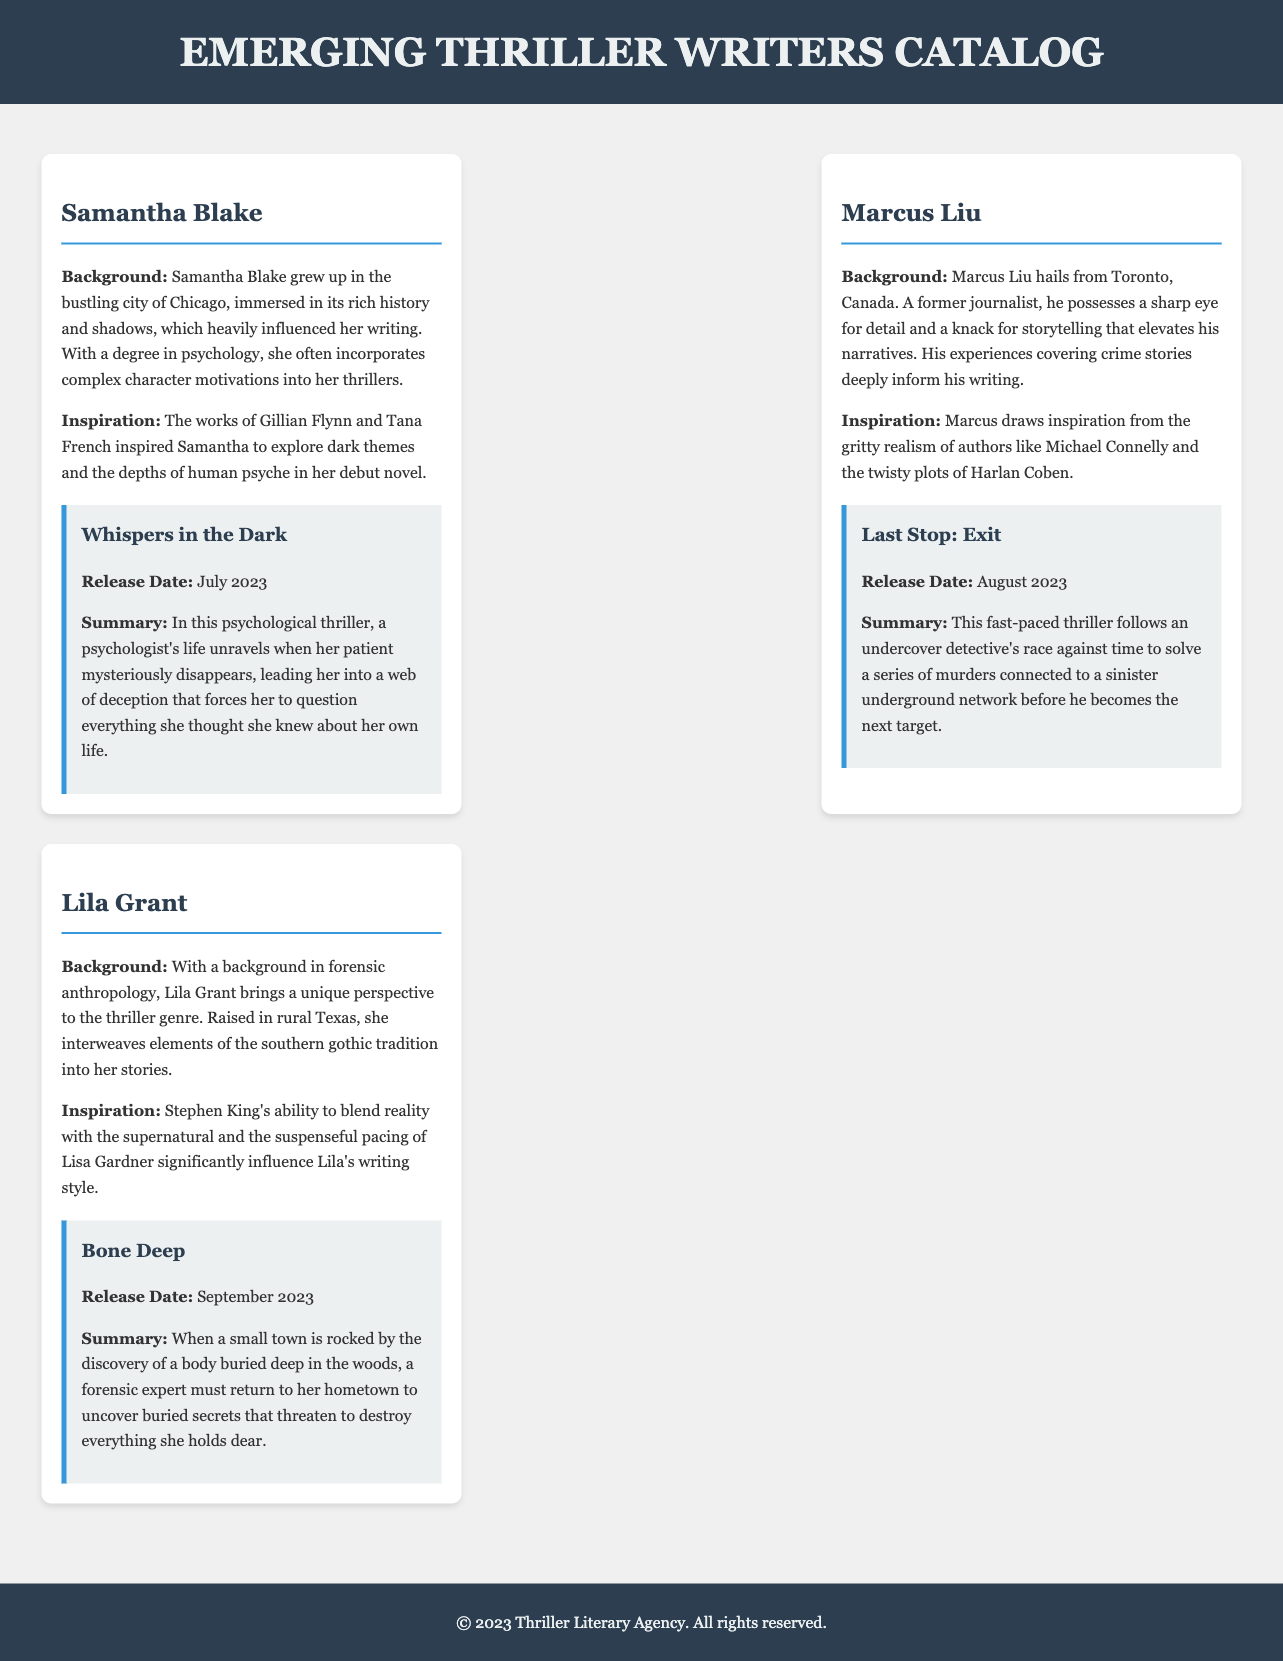What is the title of Samantha Blake's debut novel? The document states that Samantha Blake's debut novel is titled "Whispers in the Dark."
Answer: Whispers in the Dark What is Marcus Liu's background? The document mentions that Marcus Liu hails from Toronto, Canada, and is a former journalist.
Answer: Former journalist When was "Bone Deep" released? According to the document, "Bone Deep" was released in September 2023.
Answer: September 2023 Who inspired Lila Grant's writing style? The document attributes Lila Grant's writing style inspiration to Stephen King and Lisa Gardner.
Answer: Stephen King and Lisa Gardner What common theme is explored in Samantha Blake's work? The document highlights that Samantha Blake incorporates complex character motivations and dark themes in her thrillers.
Answer: Complex character motivations and dark themes Which author is associated with the fast-paced thriller in the catalog? The document identifies Marcus Liu as the author of "Last Stop: Exit," which is described as a fast-paced thriller.
Answer: Marcus Liu What unique perspective does Lila Grant bring to the thriller genre? The document indicates that Lila Grant has a background in forensic anthropology, offering a unique perspective.
Answer: Forensic anthropology What city influenced Samantha Blake's writing? The document mentions that Samantha Blake was influenced by the city of Chicago.
Answer: Chicago 